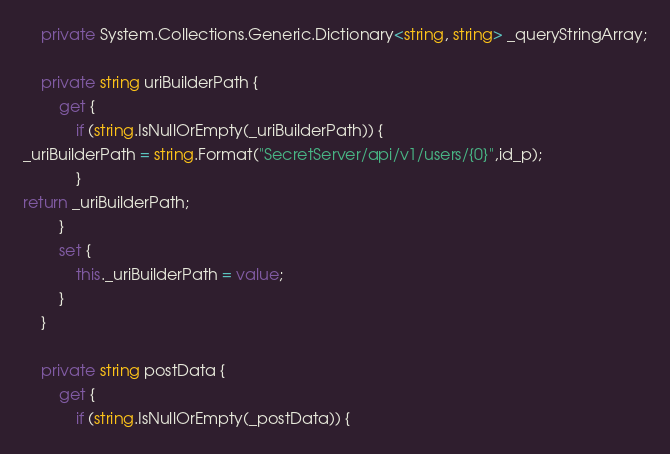Convert code to text. <code><loc_0><loc_0><loc_500><loc_500><_C#_>    private System.Collections.Generic.Dictionary<string, string> _queryStringArray;
    
    private string uriBuilderPath {
        get {
            if (string.IsNullOrEmpty(_uriBuilderPath)) {
_uriBuilderPath = string.Format("SecretServer/api/v1/users/{0}",id_p);
            }
return _uriBuilderPath;
        }
        set {
            this._uriBuilderPath = value;
        }
    }
    
    private string postData {
        get {
            if (string.IsNullOrEmpty(_postData)) {</code> 